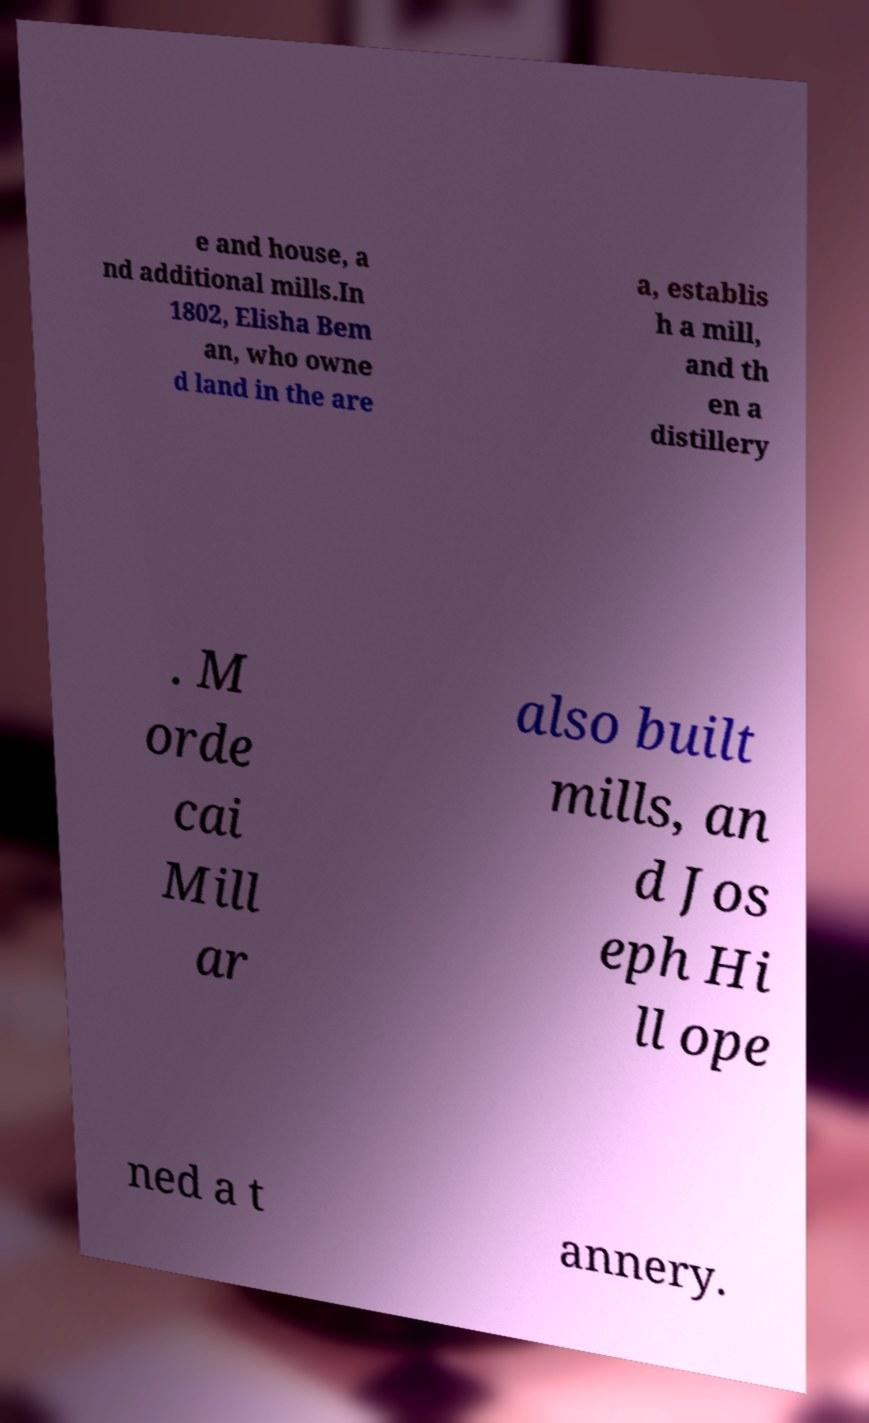Please read and relay the text visible in this image. What does it say? e and house, a nd additional mills.In 1802, Elisha Bem an, who owne d land in the are a, establis h a mill, and th en a distillery . M orde cai Mill ar also built mills, an d Jos eph Hi ll ope ned a t annery. 